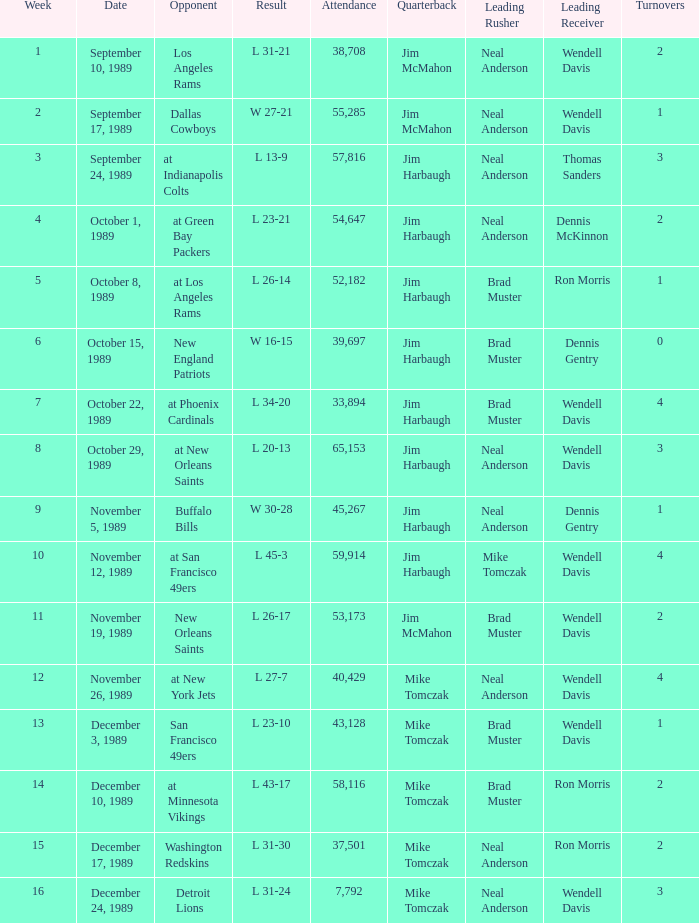On September 10, 1989 how many people attended the game? 38708.0. 